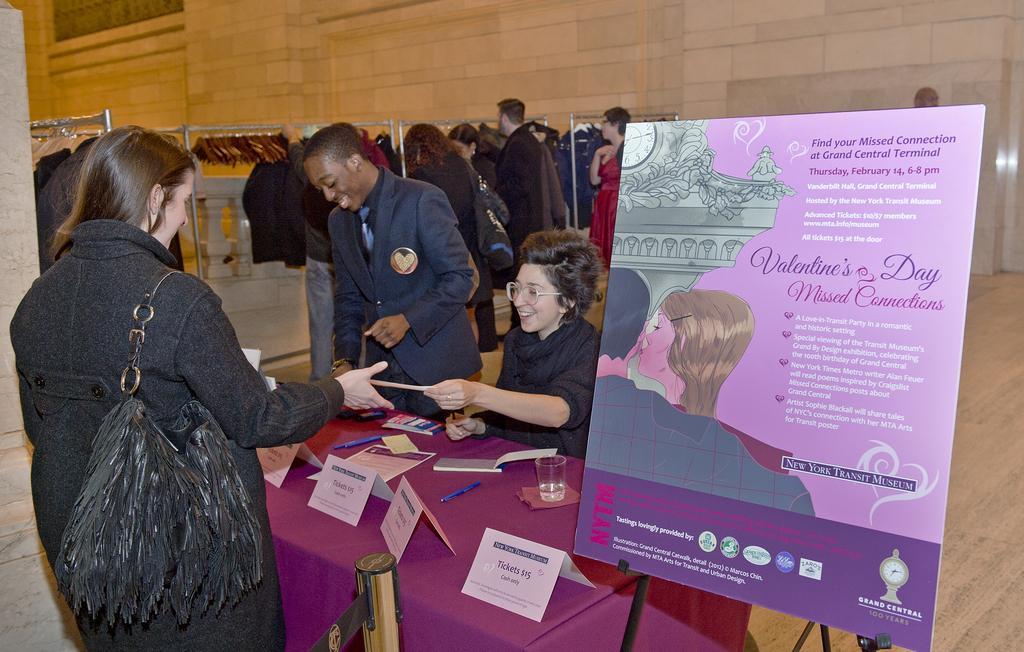How would you summarize this image in a sentence or two? In the picture I can see a woman wearing black dress is standing and there is a table in front her which has few objects placed on it and there is a woman sitting in front of her and there is another person standing beside her and there is a board placed on a stand in the right corner and there are few clothes and persons in the background. 